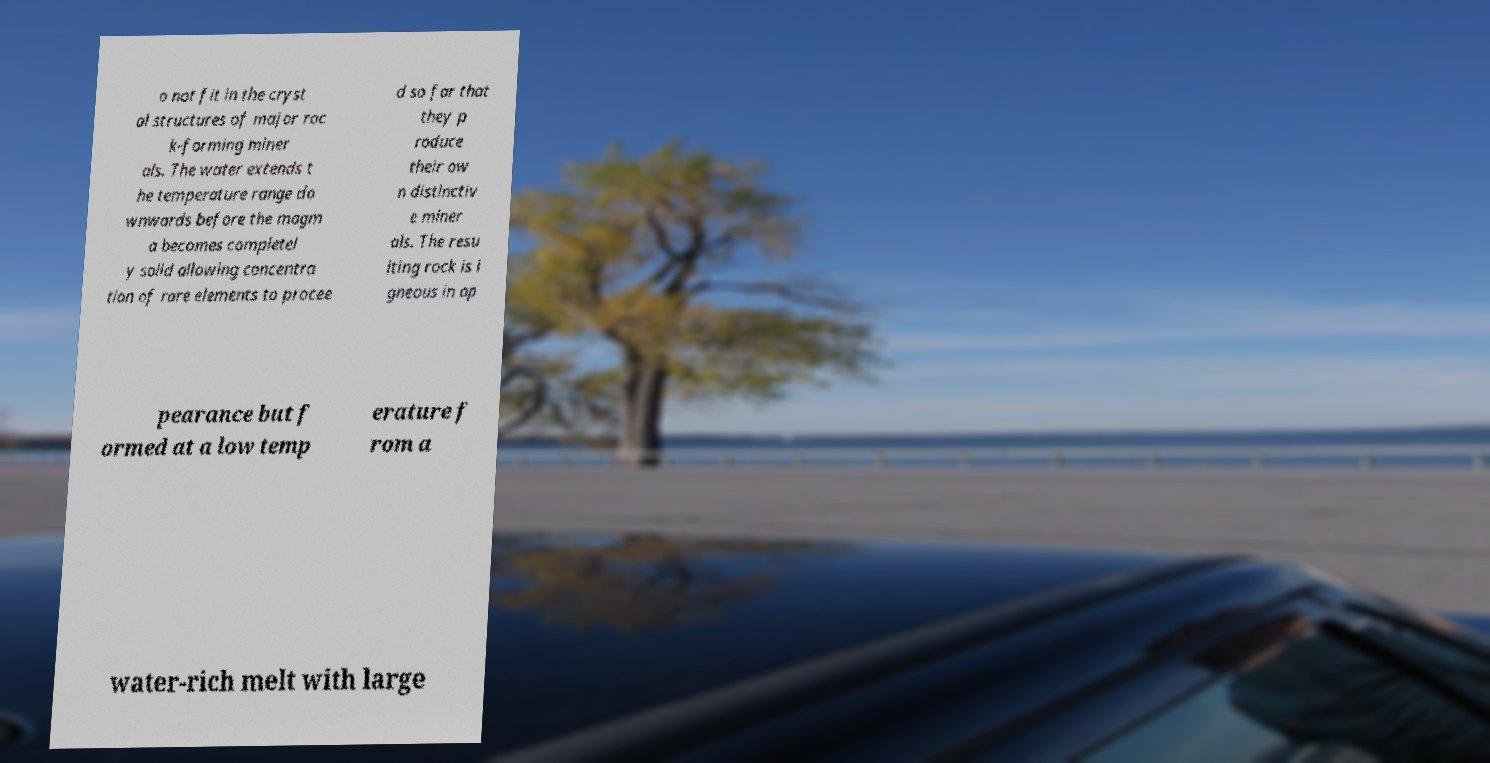What messages or text are displayed in this image? I need them in a readable, typed format. o not fit in the cryst al structures of major roc k-forming miner als. The water extends t he temperature range do wnwards before the magm a becomes completel y solid allowing concentra tion of rare elements to procee d so far that they p roduce their ow n distinctiv e miner als. The resu lting rock is i gneous in ap pearance but f ormed at a low temp erature f rom a water-rich melt with large 